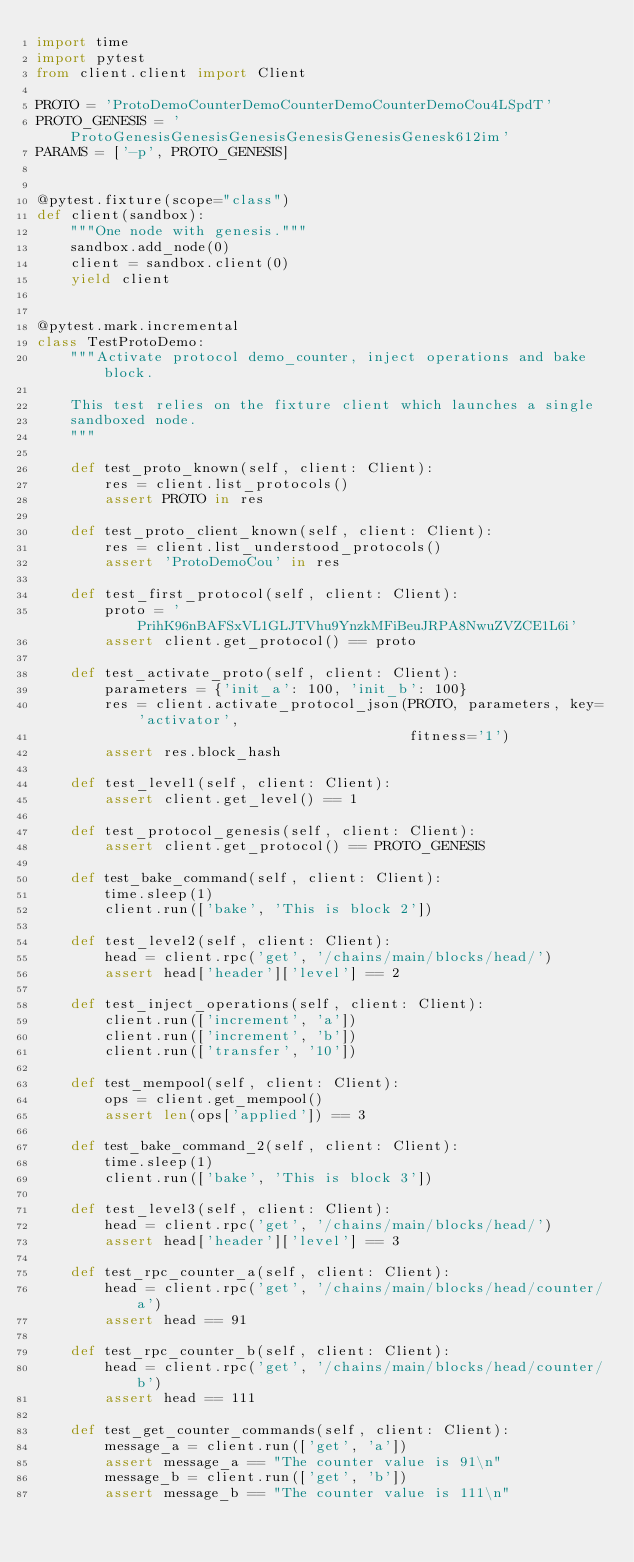Convert code to text. <code><loc_0><loc_0><loc_500><loc_500><_Python_>import time
import pytest
from client.client import Client

PROTO = 'ProtoDemoCounterDemoCounterDemoCounterDemoCou4LSpdT'
PROTO_GENESIS = 'ProtoGenesisGenesisGenesisGenesisGenesisGenesk612im'
PARAMS = ['-p', PROTO_GENESIS]


@pytest.fixture(scope="class")
def client(sandbox):
    """One node with genesis."""
    sandbox.add_node(0)
    client = sandbox.client(0)
    yield client


@pytest.mark.incremental
class TestProtoDemo:
    """Activate protocol demo_counter, inject operations and bake block.

    This test relies on the fixture client which launches a single
    sandboxed node.
    """

    def test_proto_known(self, client: Client):
        res = client.list_protocols()
        assert PROTO in res

    def test_proto_client_known(self, client: Client):
        res = client.list_understood_protocols()
        assert 'ProtoDemoCou' in res

    def test_first_protocol(self, client: Client):
        proto = 'PrihK96nBAFSxVL1GLJTVhu9YnzkMFiBeuJRPA8NwuZVZCE1L6i'
        assert client.get_protocol() == proto

    def test_activate_proto(self, client: Client):
        parameters = {'init_a': 100, 'init_b': 100}
        res = client.activate_protocol_json(PROTO, parameters, key='activator',
                                            fitness='1')
        assert res.block_hash

    def test_level1(self, client: Client):
        assert client.get_level() == 1

    def test_protocol_genesis(self, client: Client):
        assert client.get_protocol() == PROTO_GENESIS

    def test_bake_command(self, client: Client):
        time.sleep(1)
        client.run(['bake', 'This is block 2'])

    def test_level2(self, client: Client):
        head = client.rpc('get', '/chains/main/blocks/head/')
        assert head['header']['level'] == 2

    def test_inject_operations(self, client: Client):
        client.run(['increment', 'a'])
        client.run(['increment', 'b'])
        client.run(['transfer', '10'])

    def test_mempool(self, client: Client):
        ops = client.get_mempool()
        assert len(ops['applied']) == 3

    def test_bake_command_2(self, client: Client):
        time.sleep(1)
        client.run(['bake', 'This is block 3'])

    def test_level3(self, client: Client):
        head = client.rpc('get', '/chains/main/blocks/head/')
        assert head['header']['level'] == 3

    def test_rpc_counter_a(self, client: Client):
        head = client.rpc('get', '/chains/main/blocks/head/counter/a')
        assert head == 91

    def test_rpc_counter_b(self, client: Client):
        head = client.rpc('get', '/chains/main/blocks/head/counter/b')
        assert head == 111

    def test_get_counter_commands(self, client: Client):
        message_a = client.run(['get', 'a'])
        assert message_a == "The counter value is 91\n"
        message_b = client.run(['get', 'b'])
        assert message_b == "The counter value is 111\n"
</code> 